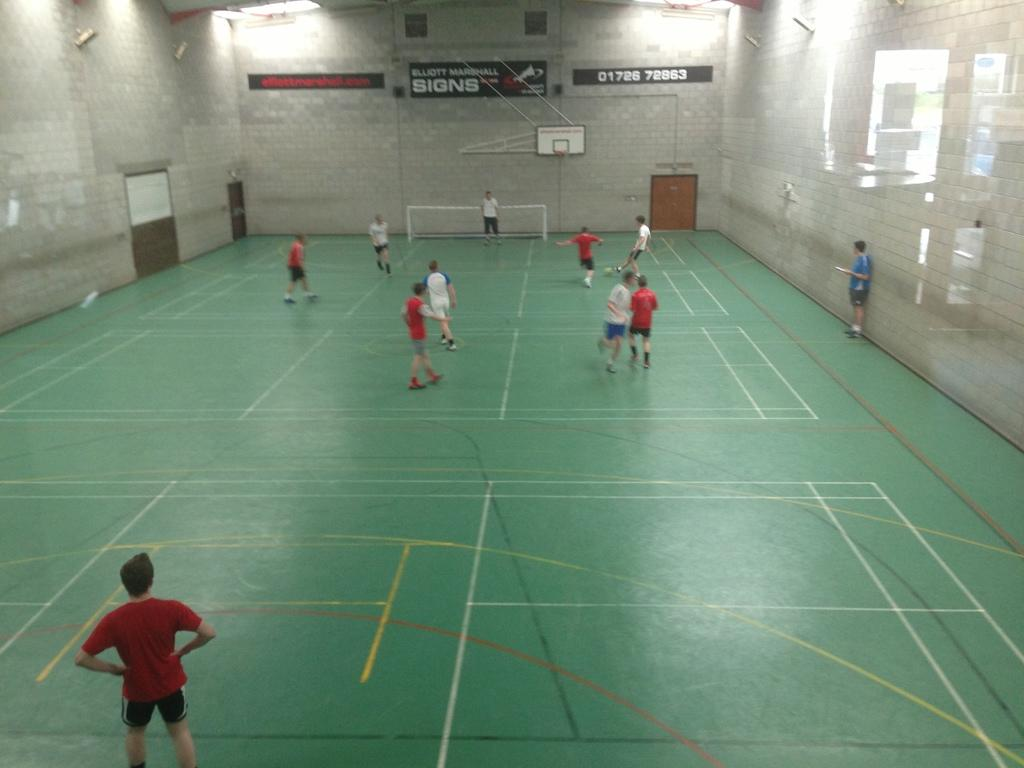<image>
Offer a succinct explanation of the picture presented. A sign for Elliott Marshall Signs hangs on the far wall of a gymnasium. 